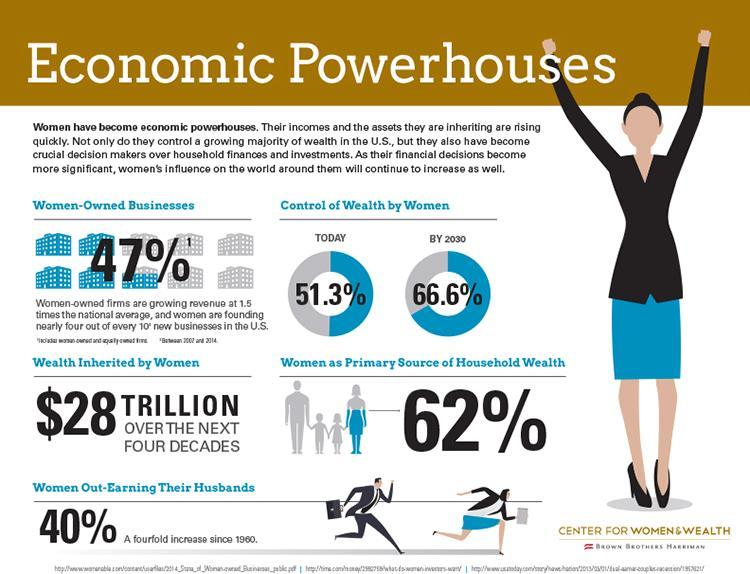What will be the percentage of wealth controlled by women by 2030, 47%, 51.3%, or 66.6%?
Answer the question with a short phrase. 66.6% 